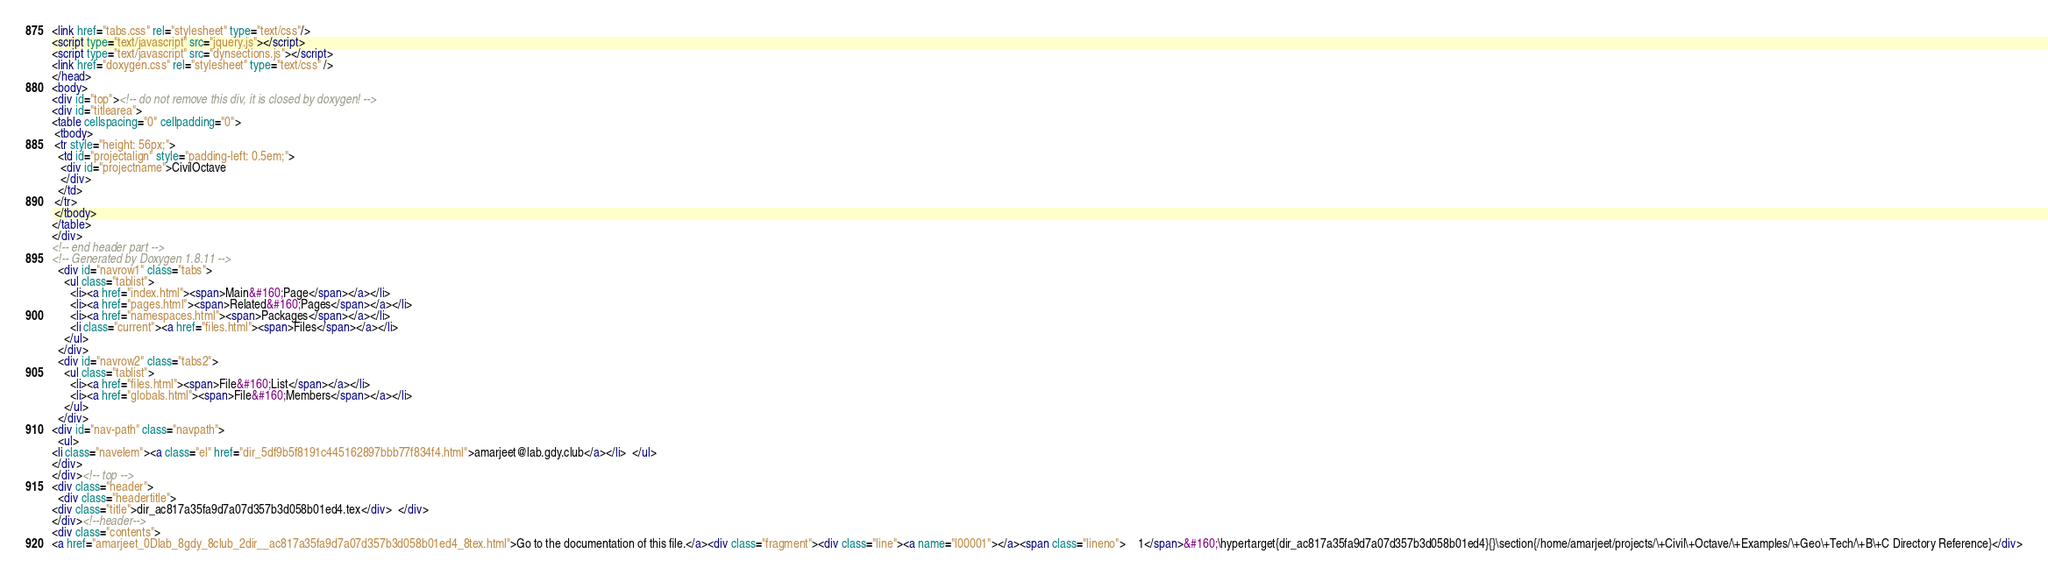<code> <loc_0><loc_0><loc_500><loc_500><_HTML_><link href="tabs.css" rel="stylesheet" type="text/css"/>
<script type="text/javascript" src="jquery.js"></script>
<script type="text/javascript" src="dynsections.js"></script>
<link href="doxygen.css" rel="stylesheet" type="text/css" />
</head>
<body>
<div id="top"><!-- do not remove this div, it is closed by doxygen! -->
<div id="titlearea">
<table cellspacing="0" cellpadding="0">
 <tbody>
 <tr style="height: 56px;">
  <td id="projectalign" style="padding-left: 0.5em;">
   <div id="projectname">CivilOctave
   </div>
  </td>
 </tr>
 </tbody>
</table>
</div>
<!-- end header part -->
<!-- Generated by Doxygen 1.8.11 -->
  <div id="navrow1" class="tabs">
    <ul class="tablist">
      <li><a href="index.html"><span>Main&#160;Page</span></a></li>
      <li><a href="pages.html"><span>Related&#160;Pages</span></a></li>
      <li><a href="namespaces.html"><span>Packages</span></a></li>
      <li class="current"><a href="files.html"><span>Files</span></a></li>
    </ul>
  </div>
  <div id="navrow2" class="tabs2">
    <ul class="tablist">
      <li><a href="files.html"><span>File&#160;List</span></a></li>
      <li><a href="globals.html"><span>File&#160;Members</span></a></li>
    </ul>
  </div>
<div id="nav-path" class="navpath">
  <ul>
<li class="navelem"><a class="el" href="dir_5df9b5f8191c445162897bbb77f834f4.html">amarjeet@lab.gdy.club</a></li>  </ul>
</div>
</div><!-- top -->
<div class="header">
  <div class="headertitle">
<div class="title">dir_ac817a35fa9d7a07d357b3d058b01ed4.tex</div>  </div>
</div><!--header-->
<div class="contents">
<a href="amarjeet_0Dlab_8gdy_8club_2dir__ac817a35fa9d7a07d357b3d058b01ed4_8tex.html">Go to the documentation of this file.</a><div class="fragment"><div class="line"><a name="l00001"></a><span class="lineno">    1</span>&#160;\hypertarget{dir_ac817a35fa9d7a07d357b3d058b01ed4}{}\section{/home/amarjeet/projects/\+Civil\+Octave/\+Examples/\+Geo\+Tech/\+B\+C Directory Reference}</div></code> 